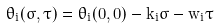<formula> <loc_0><loc_0><loc_500><loc_500>\theta _ { i } ( \sigma , \tau ) = \theta _ { i } ( 0 , 0 ) - k _ { i } \sigma - w _ { i } \tau</formula> 